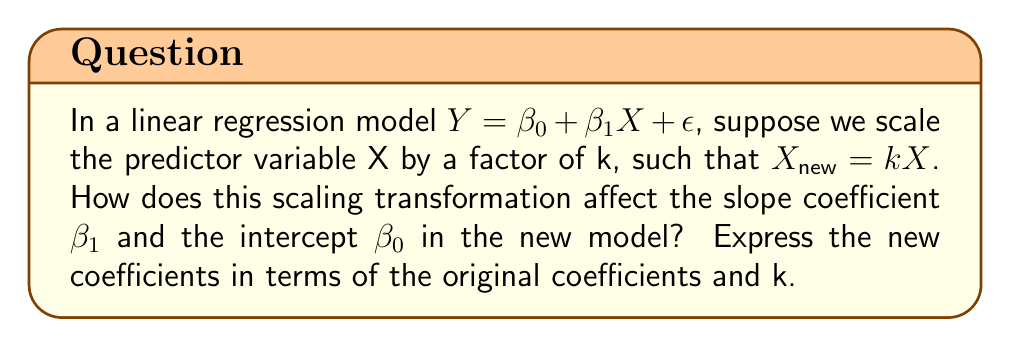Can you answer this question? Let's approach this step-by-step:

1) The original model is:
   $Y = \beta_0 + \beta_1X + \epsilon$

2) We scale X by a factor of k:
   $X_{new} = kX$

3) Substituting this into the original model:
   $Y = \beta_0 + \beta_1(\frac{X_{new}}{k}) + \epsilon$

4) Rearranging the terms:
   $Y = \beta_0 + (\frac{\beta_1}{k})X_{new} + \epsilon$

5) Now, we can identify the new coefficients:
   - The new intercept $\beta_{0,new} = \beta_0$
   - The new slope $\beta_{1,new} = \frac{\beta_1}{k}$

6) Therefore:
   - $\beta_{0,new} = \beta_0$
   - $\beta_{1,new} = \frac{\beta_1}{k}$

This shows that scaling the predictor variable by a factor of k:
- Does not change the intercept
- Divides the slope coefficient by k
Answer: $\beta_{0,new} = \beta_0$, $\beta_{1,new} = \frac{\beta_1}{k}$ 